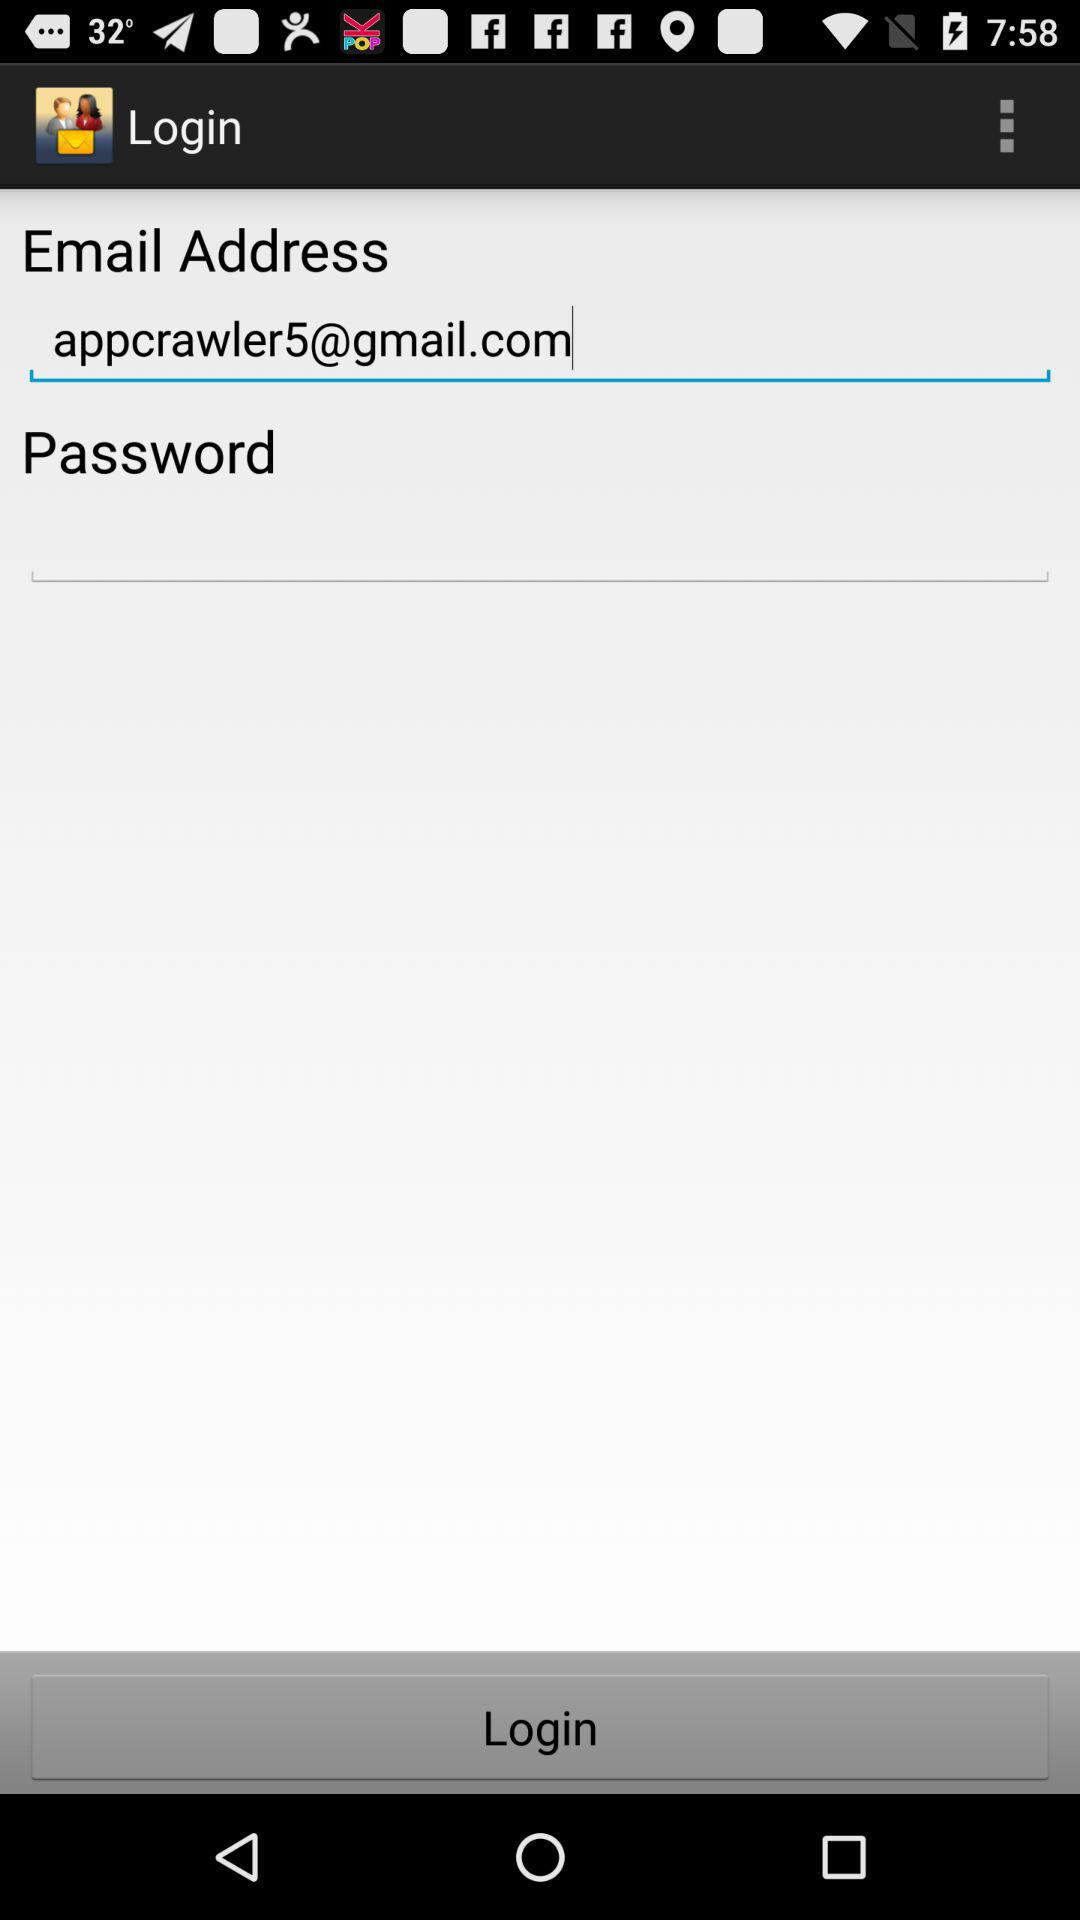What is the email address? The email address is appcrawler5@gmail.com. 